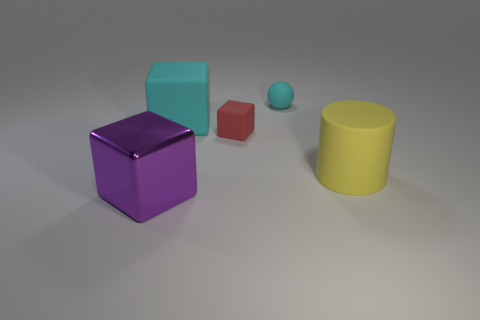Subtract all rubber cubes. How many cubes are left? 1 Subtract 1 cubes. How many cubes are left? 2 Add 4 big rubber cylinders. How many objects exist? 9 Subtract all spheres. How many objects are left? 4 Add 3 green rubber spheres. How many green rubber spheres exist? 3 Subtract 0 red spheres. How many objects are left? 5 Subtract all small red matte cylinders. Subtract all big cyan rubber cubes. How many objects are left? 4 Add 4 big cyan things. How many big cyan things are left? 5 